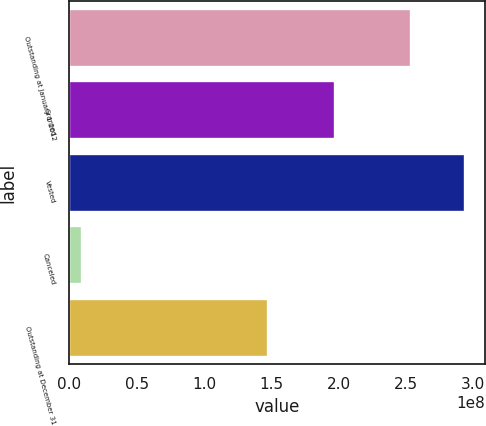Convert chart. <chart><loc_0><loc_0><loc_500><loc_500><bar_chart><fcel>Outstanding at January 1 2012<fcel>Granted<fcel>Vested<fcel>Canceled<fcel>Outstanding at December 31<nl><fcel>2.53967e+08<fcel>1.96979e+08<fcel>2.93968e+08<fcel>9.40719e+06<fcel>1.4757e+08<nl></chart> 